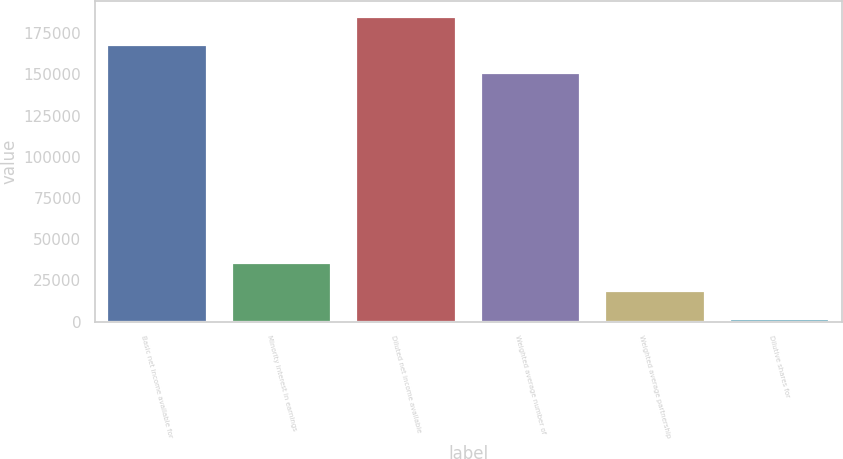<chart> <loc_0><loc_0><loc_500><loc_500><bar_chart><fcel>Basic net income available for<fcel>Minority interest in earnings<fcel>Diluted net income available<fcel>Weighted average number of<fcel>Weighted average partnership<fcel>Dilutive shares for<nl><fcel>168037<fcel>35471.8<fcel>185065<fcel>151009<fcel>18443.9<fcel>1416<nl></chart> 